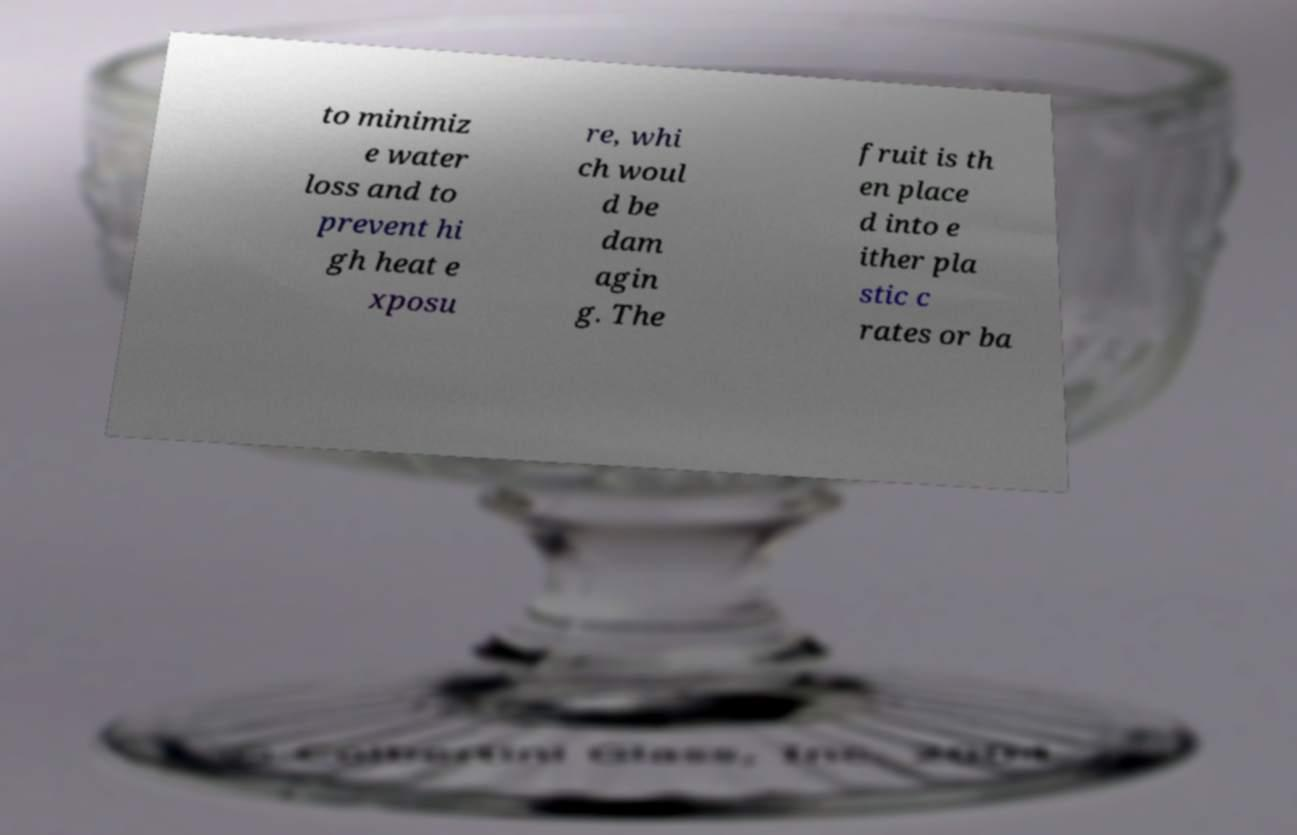There's text embedded in this image that I need extracted. Can you transcribe it verbatim? to minimiz e water loss and to prevent hi gh heat e xposu re, whi ch woul d be dam agin g. The fruit is th en place d into e ither pla stic c rates or ba 